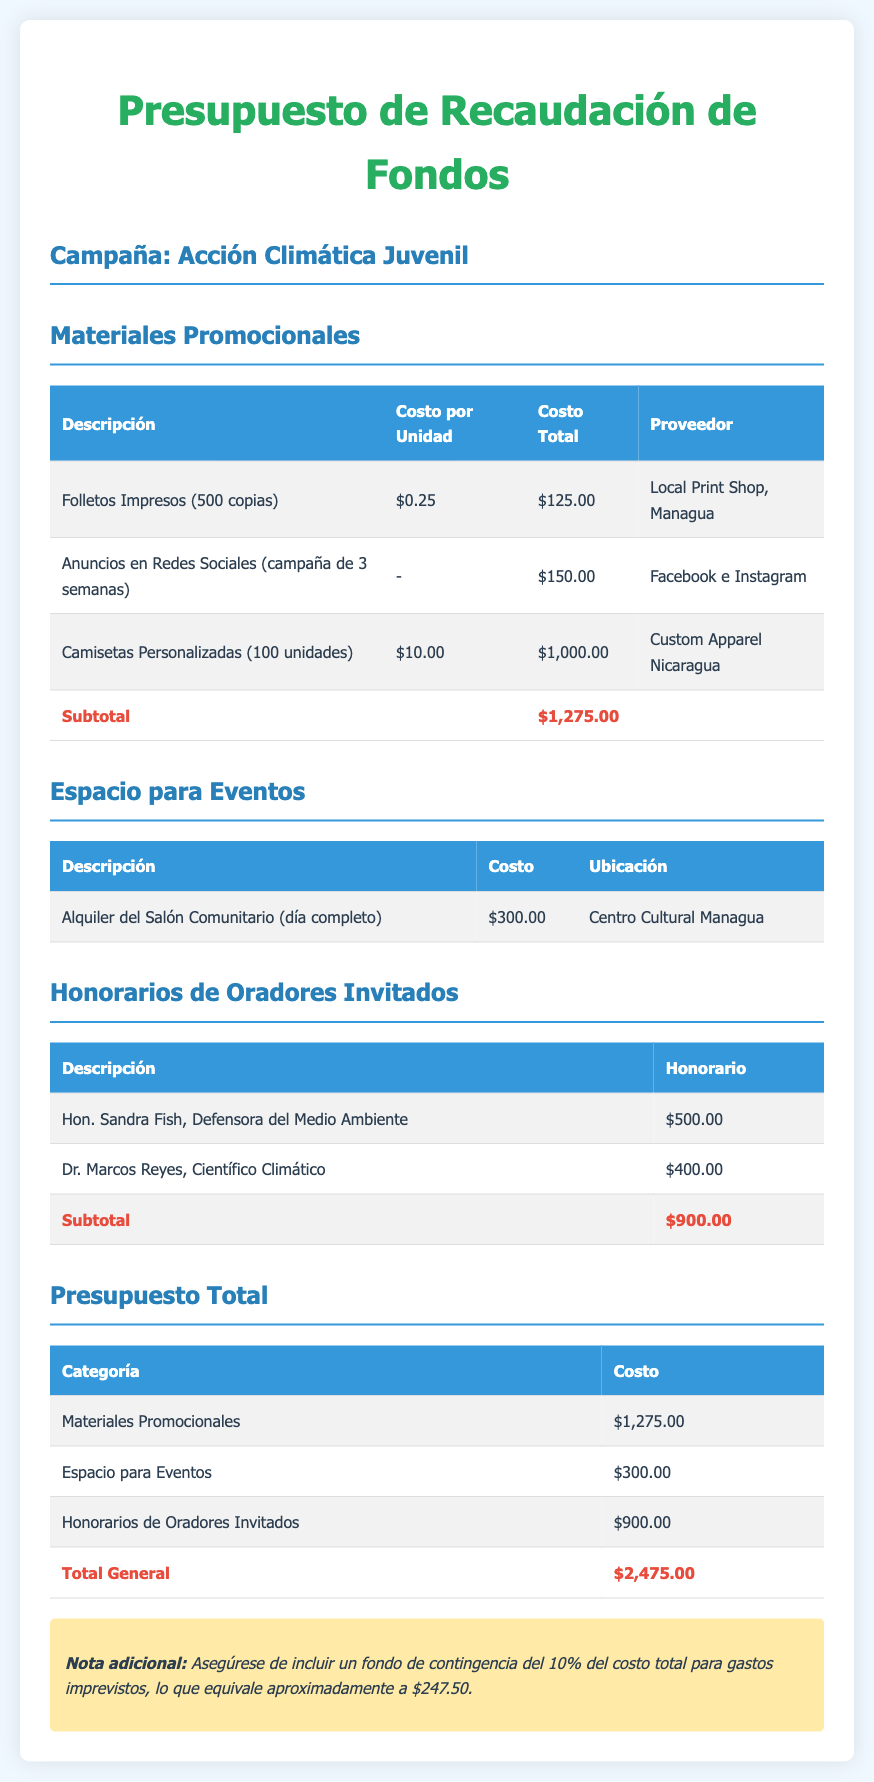¿Qué es el total del presupuesto? El total del presupuesto es la suma de los costos de todas las categorías que se presenta al final del documento.
Answer: $2,475.00 ¿Cuánto costaron los folletos impresos? El costo de los folletos impresos es específico en la tabla de materiales promocionales.
Answer: $125.00 ¿Cuál es el costo del alquiler del salón comunitario? El costo del alquiler del salón comunitario está indicado en la sección de espacio para eventos.
Answer: $300.00 ¿Quién es el orador con el honorario más alto? Este dato se puede hallar en la sección de honorarios de oradores invitados.
Answer: Hon. Sandra Fish, Defensora del Medio Ambiente ¿Cuánto es el subtotales de honorarios de oradores invitados? Este subtotal es la suma de los honorarios de los oradores en la correspondiente tabla.
Answer: $900.00 ¿Cuántas camisetas personalizadas se ordenaron? Este dato se encuentra en la tabla de materiales promocionales que detalla la cantidad de camisetas.
Answer: 100 unidades ¿Cuánto se destinará a la publicidad en redes sociales? La cantidad se especifica en la tabla de materiales promocionales en la fila de anuncios en redes sociales.
Answer: $150.00 ¿Cuál es la nota adicional sobre el presupuesto? Se menciona una recomendación sobre un fondo de contingencia para gastos imprevistos en la nota al final del documento.
Answer: $247.50 